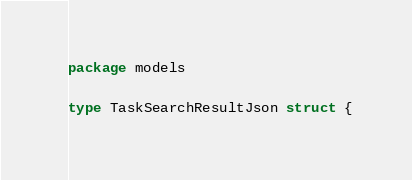<code> <loc_0><loc_0><loc_500><loc_500><_Go_>package models

type TaskSearchResultJson struct {</code> 